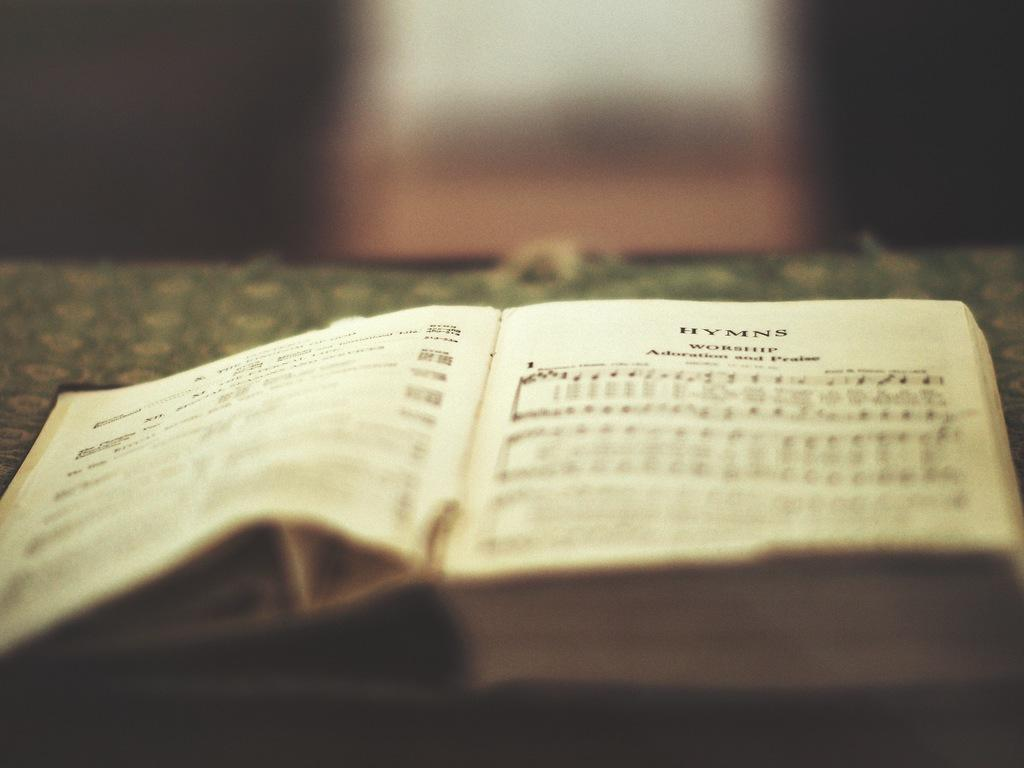<image>
Present a compact description of the photo's key features. Open book with the title "HYMNS" on the top. 